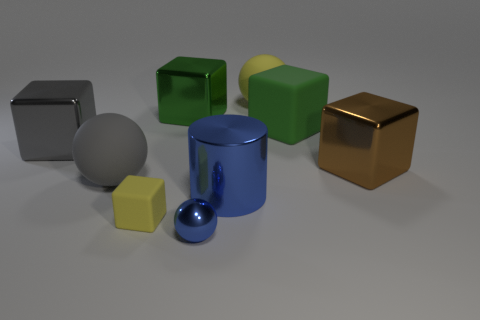Subtract all big green shiny blocks. How many blocks are left? 4 Add 1 large gray metal objects. How many objects exist? 10 Subtract all gray balls. How many balls are left? 2 Subtract all brown spheres. How many green cubes are left? 2 Subtract all balls. How many objects are left? 6 Subtract 3 balls. How many balls are left? 0 Subtract all yellow cylinders. Subtract all green spheres. How many cylinders are left? 1 Subtract all tiny gray shiny objects. Subtract all large green things. How many objects are left? 7 Add 2 big gray rubber balls. How many big gray rubber balls are left? 3 Add 1 blue shiny balls. How many blue shiny balls exist? 2 